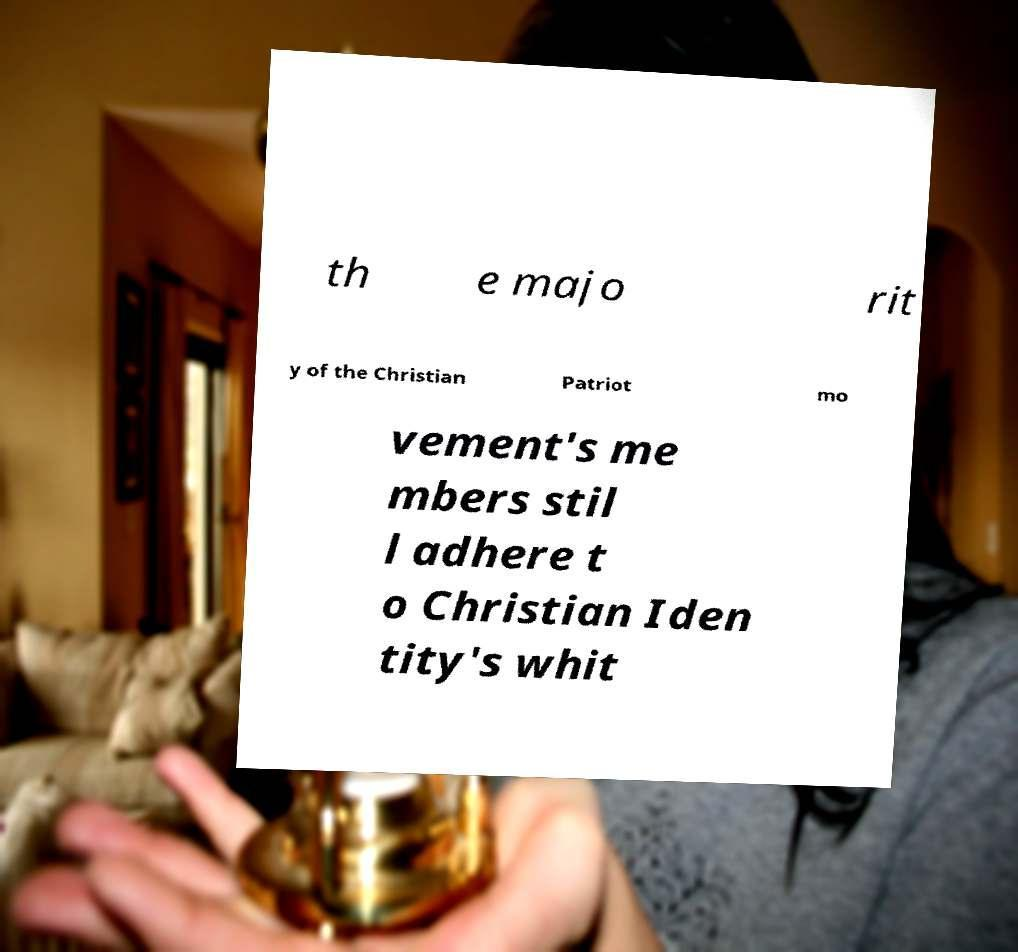Could you assist in decoding the text presented in this image and type it out clearly? th e majo rit y of the Christian Patriot mo vement's me mbers stil l adhere t o Christian Iden tity's whit 